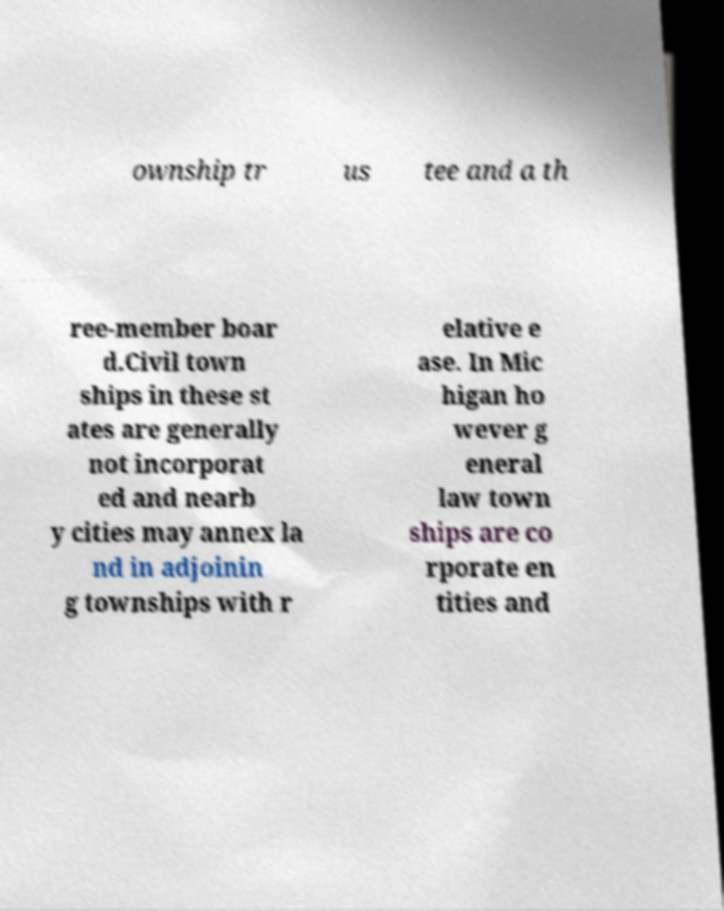Can you read and provide the text displayed in the image?This photo seems to have some interesting text. Can you extract and type it out for me? ownship tr us tee and a th ree-member boar d.Civil town ships in these st ates are generally not incorporat ed and nearb y cities may annex la nd in adjoinin g townships with r elative e ase. In Mic higan ho wever g eneral law town ships are co rporate en tities and 